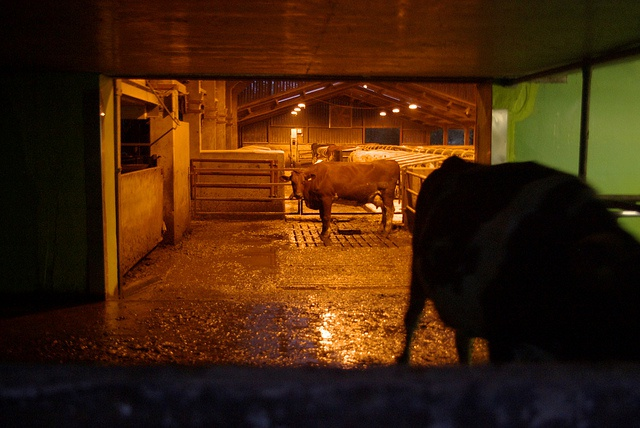Describe the objects in this image and their specific colors. I can see cow in black, maroon, brown, and orange tones, cow in black, maroon, and brown tones, cow in black, red, and maroon tones, and cow in black, orange, and tan tones in this image. 